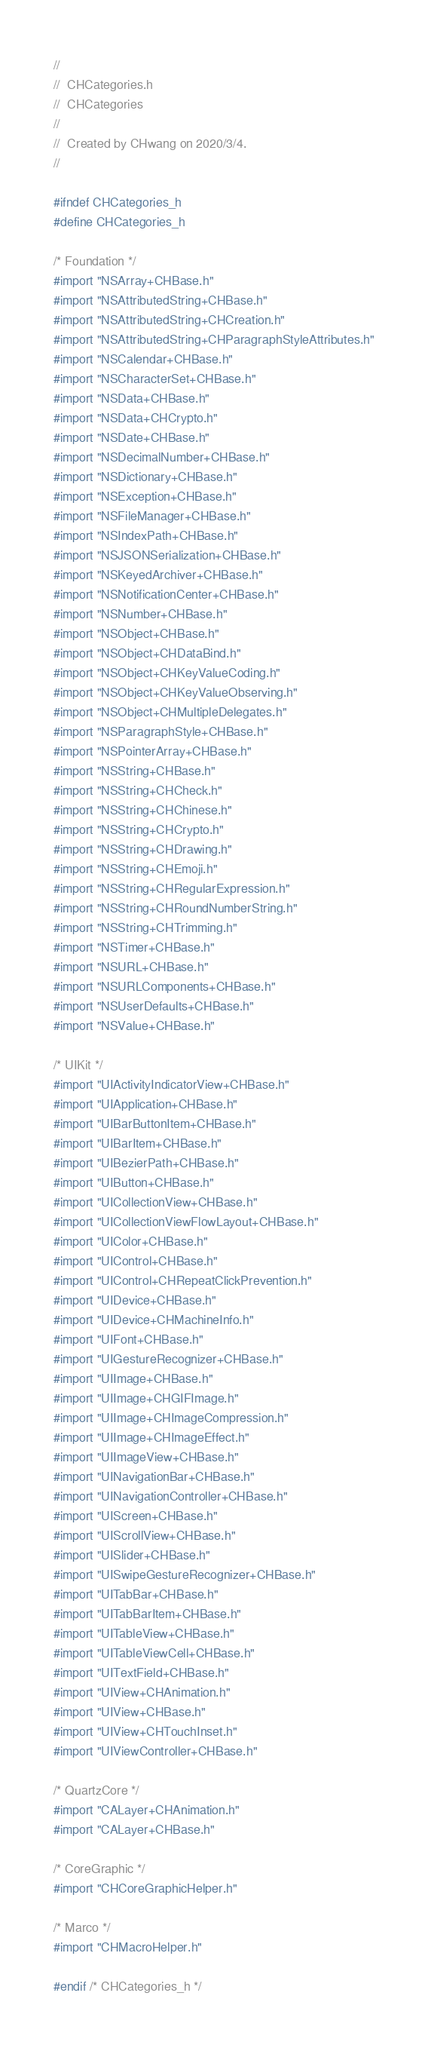<code> <loc_0><loc_0><loc_500><loc_500><_C_>//
//  CHCategories.h
//  CHCategories
//
//  Created by CHwang on 2020/3/4.
//

#ifndef CHCategories_h
#define CHCategories_h

/* Foundation */
#import "NSArray+CHBase.h"
#import "NSAttributedString+CHBase.h"
#import "NSAttributedString+CHCreation.h"
#import "NSAttributedString+CHParagraphStyleAttributes.h"
#import "NSCalendar+CHBase.h"
#import "NSCharacterSet+CHBase.h"
#import "NSData+CHBase.h"
#import "NSData+CHCrypto.h"
#import "NSDate+CHBase.h"
#import "NSDecimalNumber+CHBase.h"
#import "NSDictionary+CHBase.h"
#import "NSException+CHBase.h"
#import "NSFileManager+CHBase.h"
#import "NSIndexPath+CHBase.h"
#import "NSJSONSerialization+CHBase.h"
#import "NSKeyedArchiver+CHBase.h"
#import "NSNotificationCenter+CHBase.h"
#import "NSNumber+CHBase.h"
#import "NSObject+CHBase.h"
#import "NSObject+CHDataBind.h"
#import "NSObject+CHKeyValueCoding.h"
#import "NSObject+CHKeyValueObserving.h"
#import "NSObject+CHMultipleDelegates.h"
#import "NSParagraphStyle+CHBase.h"
#import "NSPointerArray+CHBase.h"
#import "NSString+CHBase.h"
#import "NSString+CHCheck.h"
#import "NSString+CHChinese.h"
#import "NSString+CHCrypto.h"
#import "NSString+CHDrawing.h"
#import "NSString+CHEmoji.h"
#import "NSString+CHRegularExpression.h"
#import "NSString+CHRoundNumberString.h"
#import "NSString+CHTrimming.h"
#import "NSTimer+CHBase.h"
#import "NSURL+CHBase.h"
#import "NSURLComponents+CHBase.h"
#import "NSUserDefaults+CHBase.h"
#import "NSValue+CHBase.h"

/* UIKit */
#import "UIActivityIndicatorView+CHBase.h"
#import "UIApplication+CHBase.h"
#import "UIBarButtonItem+CHBase.h"
#import "UIBarItem+CHBase.h"
#import "UIBezierPath+CHBase.h"
#import "UIButton+CHBase.h"
#import "UICollectionView+CHBase.h"
#import "UICollectionViewFlowLayout+CHBase.h"
#import "UIColor+CHBase.h"
#import "UIControl+CHBase.h"
#import "UIControl+CHRepeatClickPrevention.h"
#import "UIDevice+CHBase.h"
#import "UIDevice+CHMachineInfo.h"
#import "UIFont+CHBase.h"
#import "UIGestureRecognizer+CHBase.h"
#import "UIImage+CHBase.h"
#import "UIImage+CHGIFImage.h"
#import "UIImage+CHImageCompression.h"
#import "UIImage+CHImageEffect.h"
#import "UIImageView+CHBase.h"
#import "UINavigationBar+CHBase.h"
#import "UINavigationController+CHBase.h"
#import "UIScreen+CHBase.h"
#import "UIScrollView+CHBase.h"
#import "UISlider+CHBase.h"
#import "UISwipeGestureRecognizer+CHBase.h"
#import "UITabBar+CHBase.h"
#import "UITabBarItem+CHBase.h"
#import "UITableView+CHBase.h"
#import "UITableViewCell+CHBase.h"
#import "UITextField+CHBase.h"
#import "UIView+CHAnimation.h"
#import "UIView+CHBase.h"
#import "UIView+CHTouchInset.h"
#import "UIViewController+CHBase.h"

/* QuartzCore */
#import "CALayer+CHAnimation.h"
#import "CALayer+CHBase.h"

/* CoreGraphic */
#import "CHCoreGraphicHelper.h"

/* Marco */
#import "CHMacroHelper.h"

#endif /* CHCategories_h */
</code> 